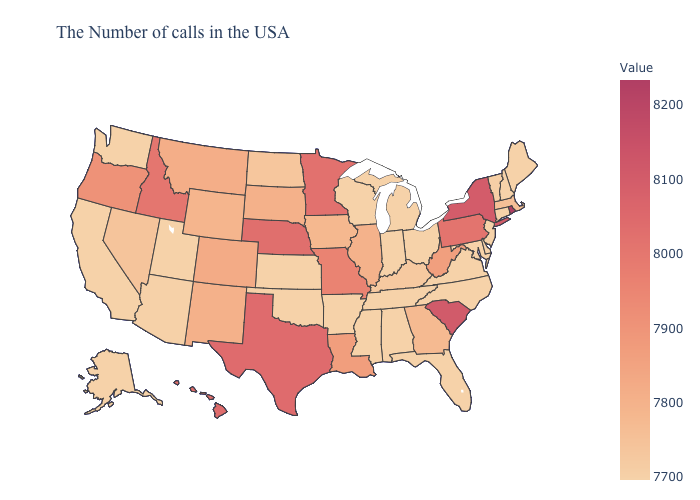Does the map have missing data?
Answer briefly. No. Which states have the lowest value in the USA?
Keep it brief. Maine, New Hampshire, Connecticut, New Jersey, Delaware, Maryland, Virginia, North Carolina, Ohio, Florida, Michigan, Indiana, Alabama, Tennessee, Wisconsin, Mississippi, Arkansas, Kansas, Oklahoma, Utah, California, Washington, Alaska. Does Utah have a higher value than Wyoming?
Quick response, please. No. Which states have the lowest value in the MidWest?
Answer briefly. Ohio, Michigan, Indiana, Wisconsin, Kansas. 